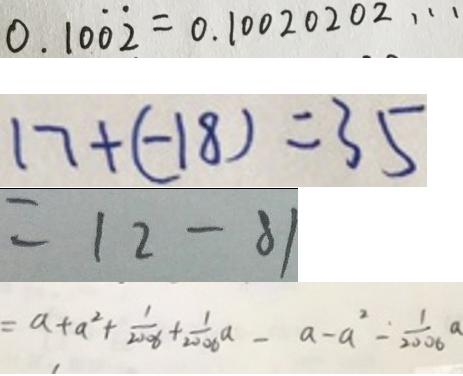<formula> <loc_0><loc_0><loc_500><loc_500>0 . 1 0 \dot { 0 } \dot { 2 } = 0 . 1 0 0 2 0 2 0 2 \cdots 
 1 7 + ( - 1 8 ) = 3 5 
 = 1 2 - 8 1 
 = a + a ^ { 2 } + \frac { 1 } { 2 0 0 6 } + \frac { 1 } { 2 0 0 6 } a - a - a ^ { 2 } - \frac { 1 } { 2 0 0 6 } a</formula> 